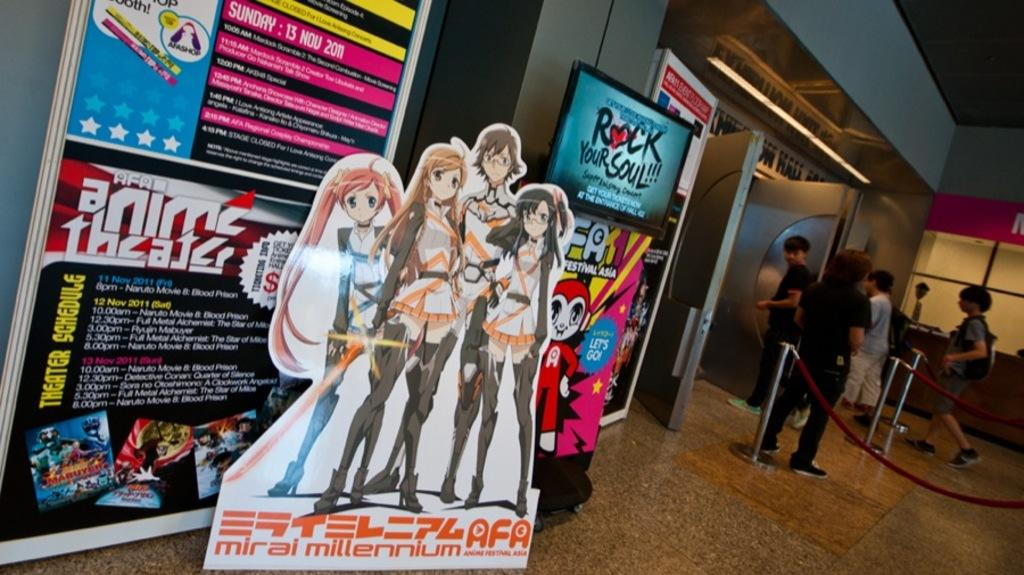<image>
Offer a succinct explanation of the picture presented. A display in a theater that says, "Anime Theater". 